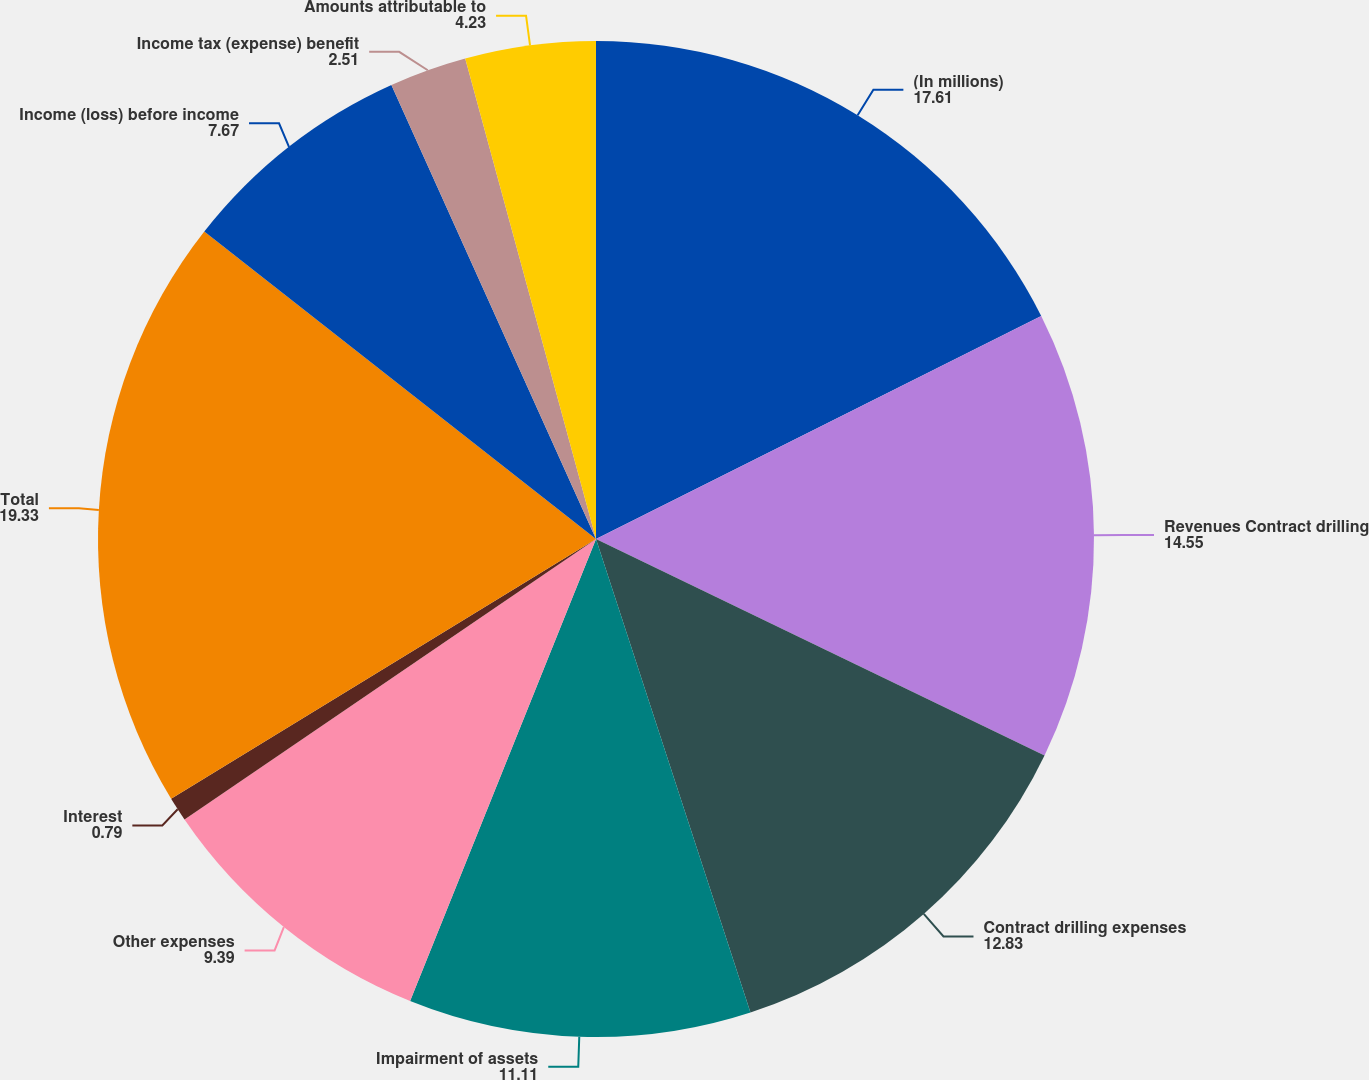Convert chart. <chart><loc_0><loc_0><loc_500><loc_500><pie_chart><fcel>(In millions)<fcel>Revenues Contract drilling<fcel>Contract drilling expenses<fcel>Impairment of assets<fcel>Other expenses<fcel>Interest<fcel>Total<fcel>Income (loss) before income<fcel>Income tax (expense) benefit<fcel>Amounts attributable to<nl><fcel>17.61%<fcel>14.55%<fcel>12.83%<fcel>11.11%<fcel>9.39%<fcel>0.79%<fcel>19.33%<fcel>7.67%<fcel>2.51%<fcel>4.23%<nl></chart> 